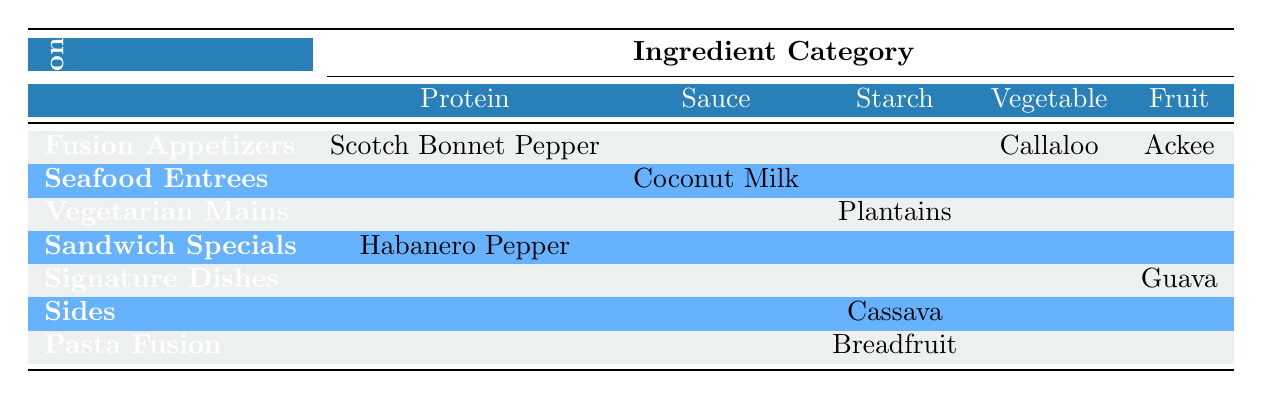What ingredient is used in the Signature Dishes section? The Signature Dishes section lists one ingredient, which is Guava.
Answer: Guava Which menu section features the highest number of ingredient categories? The table indicates multiple sections, but Fusion Appetizers contains ingredients from two categories: Protein and Vegetable. No other sections contain more than one category.
Answer: Fusion Appetizers Does the Seafood Entrees section include a Protein ingredient? The table clearly shows that the Seafood Entrees section contains Coconut Milk, categorized as Sauce, and there is no Protein ingredient listed in this section.
Answer: No How many different Starch ingredients are used across all menu sections? The Starch ingredients are Plantains, Cassava, and Breadfruit. Counting these gives us a total of three different Starch ingredients.
Answer: 3 In the Pasta Fusion menu section, what is the Starch ingredient used? The Pasta Fusion section specifically lists Breadfruit as the Starch ingredient.
Answer: Breadfruit Is there any dish in the Fusion Appetizers section that contains a Sweet flavor profile? The table shows that the Fusion Appetizers section includes Callaloo, which has an Earthy flavor profile, and Ackee, which is Savory. Therefore, there are no Sweet flavor profiles in this section.
Answer: No How many dishes contain a Spicy flavor profile, and which are they? Looking at the table, the dishes that have a Spicy flavor profile are Jerk Chicken Tacos with Scotch Bonnet Pepper and Mango Habanero Pulled Pork with Habanero Pepper. So, there are two dishes with this profile.
Answer: 2 dishes (Jerk Chicken Tacos, Mango Habanero Pulled Pork) Which Caribbean country is represented by the ingredient used in the Vegetarian Mains section? The Vegetarian Mains section uses Plantains, which originate from Puerto Rico.
Answer: Puerto Rico What are the ingredients used in the Sandwich Specials menu section? The Sandwich Specials section lists Habanero Pepper under the Protein category as the only ingredient mentioned.
Answer: Habanero Pepper 